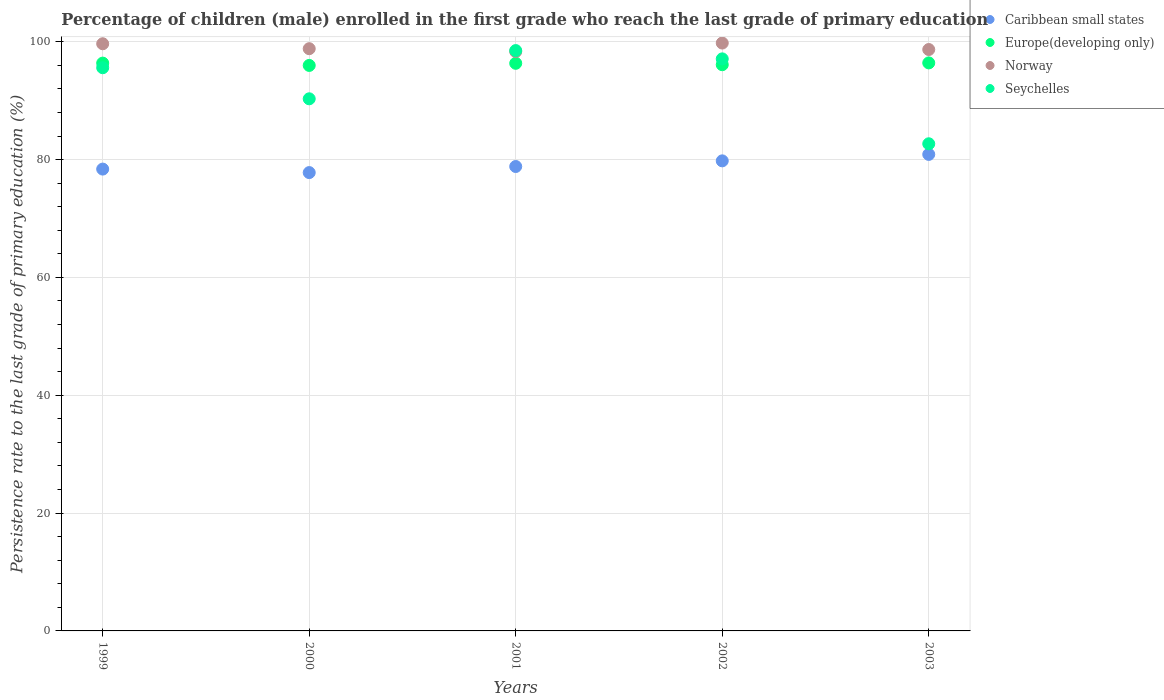Is the number of dotlines equal to the number of legend labels?
Your response must be concise. Yes. What is the persistence rate of children in Seychelles in 2002?
Give a very brief answer. 97.1. Across all years, what is the maximum persistence rate of children in Europe(developing only)?
Offer a terse response. 96.41. Across all years, what is the minimum persistence rate of children in Caribbean small states?
Keep it short and to the point. 77.79. In which year was the persistence rate of children in Caribbean small states maximum?
Provide a short and direct response. 2003. In which year was the persistence rate of children in Caribbean small states minimum?
Your response must be concise. 2000. What is the total persistence rate of children in Europe(developing only) in the graph?
Offer a very short reply. 481.22. What is the difference between the persistence rate of children in Europe(developing only) in 2000 and that in 2001?
Offer a terse response. -0.36. What is the difference between the persistence rate of children in Caribbean small states in 1999 and the persistence rate of children in Norway in 2000?
Give a very brief answer. -20.44. What is the average persistence rate of children in Caribbean small states per year?
Your answer should be very brief. 79.14. In the year 2001, what is the difference between the persistence rate of children in Europe(developing only) and persistence rate of children in Norway?
Your answer should be very brief. -1.98. In how many years, is the persistence rate of children in Norway greater than 48 %?
Offer a very short reply. 5. What is the ratio of the persistence rate of children in Seychelles in 2002 to that in 2003?
Make the answer very short. 1.17. Is the persistence rate of children in Norway in 2001 less than that in 2003?
Your response must be concise. Yes. What is the difference between the highest and the second highest persistence rate of children in Norway?
Your response must be concise. 0.12. What is the difference between the highest and the lowest persistence rate of children in Norway?
Your answer should be very brief. 1.45. Is it the case that in every year, the sum of the persistence rate of children in Europe(developing only) and persistence rate of children in Seychelles  is greater than the sum of persistence rate of children in Norway and persistence rate of children in Caribbean small states?
Give a very brief answer. No. How many dotlines are there?
Keep it short and to the point. 4. How many years are there in the graph?
Provide a short and direct response. 5. Does the graph contain grids?
Give a very brief answer. Yes. Where does the legend appear in the graph?
Your answer should be compact. Top right. How many legend labels are there?
Your answer should be very brief. 4. What is the title of the graph?
Keep it short and to the point. Percentage of children (male) enrolled in the first grade who reach the last grade of primary education. What is the label or title of the X-axis?
Offer a terse response. Years. What is the label or title of the Y-axis?
Your answer should be very brief. Persistence rate to the last grade of primary education (%). What is the Persistence rate to the last grade of primary education (%) in Caribbean small states in 1999?
Your answer should be compact. 78.39. What is the Persistence rate to the last grade of primary education (%) of Europe(developing only) in 1999?
Offer a terse response. 96.38. What is the Persistence rate to the last grade of primary education (%) of Norway in 1999?
Your answer should be very brief. 99.66. What is the Persistence rate to the last grade of primary education (%) of Seychelles in 1999?
Provide a succinct answer. 95.59. What is the Persistence rate to the last grade of primary education (%) in Caribbean small states in 2000?
Keep it short and to the point. 77.79. What is the Persistence rate to the last grade of primary education (%) of Europe(developing only) in 2000?
Make the answer very short. 95.98. What is the Persistence rate to the last grade of primary education (%) in Norway in 2000?
Give a very brief answer. 98.82. What is the Persistence rate to the last grade of primary education (%) in Seychelles in 2000?
Offer a very short reply. 90.32. What is the Persistence rate to the last grade of primary education (%) of Caribbean small states in 2001?
Provide a short and direct response. 78.83. What is the Persistence rate to the last grade of primary education (%) in Europe(developing only) in 2001?
Offer a very short reply. 96.34. What is the Persistence rate to the last grade of primary education (%) in Norway in 2001?
Provide a short and direct response. 98.33. What is the Persistence rate to the last grade of primary education (%) of Seychelles in 2001?
Ensure brevity in your answer.  98.5. What is the Persistence rate to the last grade of primary education (%) in Caribbean small states in 2002?
Ensure brevity in your answer.  79.79. What is the Persistence rate to the last grade of primary education (%) in Europe(developing only) in 2002?
Provide a short and direct response. 96.1. What is the Persistence rate to the last grade of primary education (%) of Norway in 2002?
Offer a terse response. 99.78. What is the Persistence rate to the last grade of primary education (%) of Seychelles in 2002?
Offer a terse response. 97.1. What is the Persistence rate to the last grade of primary education (%) in Caribbean small states in 2003?
Offer a terse response. 80.88. What is the Persistence rate to the last grade of primary education (%) of Europe(developing only) in 2003?
Your answer should be compact. 96.41. What is the Persistence rate to the last grade of primary education (%) of Norway in 2003?
Offer a very short reply. 98.68. What is the Persistence rate to the last grade of primary education (%) of Seychelles in 2003?
Make the answer very short. 82.68. Across all years, what is the maximum Persistence rate to the last grade of primary education (%) of Caribbean small states?
Provide a succinct answer. 80.88. Across all years, what is the maximum Persistence rate to the last grade of primary education (%) of Europe(developing only)?
Provide a short and direct response. 96.41. Across all years, what is the maximum Persistence rate to the last grade of primary education (%) of Norway?
Offer a terse response. 99.78. Across all years, what is the maximum Persistence rate to the last grade of primary education (%) of Seychelles?
Give a very brief answer. 98.5. Across all years, what is the minimum Persistence rate to the last grade of primary education (%) of Caribbean small states?
Your response must be concise. 77.79. Across all years, what is the minimum Persistence rate to the last grade of primary education (%) of Europe(developing only)?
Offer a very short reply. 95.98. Across all years, what is the minimum Persistence rate to the last grade of primary education (%) in Norway?
Provide a succinct answer. 98.33. Across all years, what is the minimum Persistence rate to the last grade of primary education (%) of Seychelles?
Give a very brief answer. 82.68. What is the total Persistence rate to the last grade of primary education (%) of Caribbean small states in the graph?
Give a very brief answer. 395.68. What is the total Persistence rate to the last grade of primary education (%) in Europe(developing only) in the graph?
Ensure brevity in your answer.  481.22. What is the total Persistence rate to the last grade of primary education (%) in Norway in the graph?
Provide a short and direct response. 495.27. What is the total Persistence rate to the last grade of primary education (%) of Seychelles in the graph?
Offer a terse response. 464.19. What is the difference between the Persistence rate to the last grade of primary education (%) in Caribbean small states in 1999 and that in 2000?
Your answer should be compact. 0.59. What is the difference between the Persistence rate to the last grade of primary education (%) of Europe(developing only) in 1999 and that in 2000?
Make the answer very short. 0.39. What is the difference between the Persistence rate to the last grade of primary education (%) in Norway in 1999 and that in 2000?
Your answer should be very brief. 0.84. What is the difference between the Persistence rate to the last grade of primary education (%) of Seychelles in 1999 and that in 2000?
Provide a short and direct response. 5.27. What is the difference between the Persistence rate to the last grade of primary education (%) of Caribbean small states in 1999 and that in 2001?
Ensure brevity in your answer.  -0.44. What is the difference between the Persistence rate to the last grade of primary education (%) of Europe(developing only) in 1999 and that in 2001?
Provide a short and direct response. 0.03. What is the difference between the Persistence rate to the last grade of primary education (%) of Norway in 1999 and that in 2001?
Give a very brief answer. 1.33. What is the difference between the Persistence rate to the last grade of primary education (%) of Seychelles in 1999 and that in 2001?
Your answer should be very brief. -2.91. What is the difference between the Persistence rate to the last grade of primary education (%) in Caribbean small states in 1999 and that in 2002?
Give a very brief answer. -1.4. What is the difference between the Persistence rate to the last grade of primary education (%) in Europe(developing only) in 1999 and that in 2002?
Your response must be concise. 0.27. What is the difference between the Persistence rate to the last grade of primary education (%) in Norway in 1999 and that in 2002?
Your answer should be compact. -0.12. What is the difference between the Persistence rate to the last grade of primary education (%) of Seychelles in 1999 and that in 2002?
Provide a short and direct response. -1.5. What is the difference between the Persistence rate to the last grade of primary education (%) of Caribbean small states in 1999 and that in 2003?
Your response must be concise. -2.49. What is the difference between the Persistence rate to the last grade of primary education (%) in Europe(developing only) in 1999 and that in 2003?
Provide a short and direct response. -0.04. What is the difference between the Persistence rate to the last grade of primary education (%) of Norway in 1999 and that in 2003?
Keep it short and to the point. 0.98. What is the difference between the Persistence rate to the last grade of primary education (%) of Seychelles in 1999 and that in 2003?
Ensure brevity in your answer.  12.91. What is the difference between the Persistence rate to the last grade of primary education (%) in Caribbean small states in 2000 and that in 2001?
Provide a succinct answer. -1.03. What is the difference between the Persistence rate to the last grade of primary education (%) in Europe(developing only) in 2000 and that in 2001?
Offer a very short reply. -0.36. What is the difference between the Persistence rate to the last grade of primary education (%) in Norway in 2000 and that in 2001?
Give a very brief answer. 0.5. What is the difference between the Persistence rate to the last grade of primary education (%) in Seychelles in 2000 and that in 2001?
Your response must be concise. -8.19. What is the difference between the Persistence rate to the last grade of primary education (%) of Caribbean small states in 2000 and that in 2002?
Offer a very short reply. -1.99. What is the difference between the Persistence rate to the last grade of primary education (%) in Europe(developing only) in 2000 and that in 2002?
Offer a terse response. -0.12. What is the difference between the Persistence rate to the last grade of primary education (%) of Norway in 2000 and that in 2002?
Keep it short and to the point. -0.96. What is the difference between the Persistence rate to the last grade of primary education (%) in Seychelles in 2000 and that in 2002?
Your answer should be compact. -6.78. What is the difference between the Persistence rate to the last grade of primary education (%) in Caribbean small states in 2000 and that in 2003?
Offer a terse response. -3.09. What is the difference between the Persistence rate to the last grade of primary education (%) in Europe(developing only) in 2000 and that in 2003?
Offer a terse response. -0.43. What is the difference between the Persistence rate to the last grade of primary education (%) of Norway in 2000 and that in 2003?
Offer a very short reply. 0.14. What is the difference between the Persistence rate to the last grade of primary education (%) of Seychelles in 2000 and that in 2003?
Offer a very short reply. 7.63. What is the difference between the Persistence rate to the last grade of primary education (%) of Caribbean small states in 2001 and that in 2002?
Your answer should be compact. -0.96. What is the difference between the Persistence rate to the last grade of primary education (%) in Europe(developing only) in 2001 and that in 2002?
Provide a succinct answer. 0.24. What is the difference between the Persistence rate to the last grade of primary education (%) of Norway in 2001 and that in 2002?
Your answer should be very brief. -1.45. What is the difference between the Persistence rate to the last grade of primary education (%) in Seychelles in 2001 and that in 2002?
Make the answer very short. 1.41. What is the difference between the Persistence rate to the last grade of primary education (%) of Caribbean small states in 2001 and that in 2003?
Offer a terse response. -2.06. What is the difference between the Persistence rate to the last grade of primary education (%) in Europe(developing only) in 2001 and that in 2003?
Ensure brevity in your answer.  -0.07. What is the difference between the Persistence rate to the last grade of primary education (%) of Norway in 2001 and that in 2003?
Your answer should be very brief. -0.36. What is the difference between the Persistence rate to the last grade of primary education (%) in Seychelles in 2001 and that in 2003?
Offer a terse response. 15.82. What is the difference between the Persistence rate to the last grade of primary education (%) of Caribbean small states in 2002 and that in 2003?
Your answer should be very brief. -1.1. What is the difference between the Persistence rate to the last grade of primary education (%) in Europe(developing only) in 2002 and that in 2003?
Offer a terse response. -0.31. What is the difference between the Persistence rate to the last grade of primary education (%) of Norway in 2002 and that in 2003?
Keep it short and to the point. 1.1. What is the difference between the Persistence rate to the last grade of primary education (%) of Seychelles in 2002 and that in 2003?
Offer a very short reply. 14.41. What is the difference between the Persistence rate to the last grade of primary education (%) of Caribbean small states in 1999 and the Persistence rate to the last grade of primary education (%) of Europe(developing only) in 2000?
Ensure brevity in your answer.  -17.6. What is the difference between the Persistence rate to the last grade of primary education (%) of Caribbean small states in 1999 and the Persistence rate to the last grade of primary education (%) of Norway in 2000?
Give a very brief answer. -20.44. What is the difference between the Persistence rate to the last grade of primary education (%) of Caribbean small states in 1999 and the Persistence rate to the last grade of primary education (%) of Seychelles in 2000?
Offer a terse response. -11.93. What is the difference between the Persistence rate to the last grade of primary education (%) of Europe(developing only) in 1999 and the Persistence rate to the last grade of primary education (%) of Norway in 2000?
Your answer should be compact. -2.45. What is the difference between the Persistence rate to the last grade of primary education (%) of Europe(developing only) in 1999 and the Persistence rate to the last grade of primary education (%) of Seychelles in 2000?
Keep it short and to the point. 6.06. What is the difference between the Persistence rate to the last grade of primary education (%) of Norway in 1999 and the Persistence rate to the last grade of primary education (%) of Seychelles in 2000?
Provide a short and direct response. 9.34. What is the difference between the Persistence rate to the last grade of primary education (%) in Caribbean small states in 1999 and the Persistence rate to the last grade of primary education (%) in Europe(developing only) in 2001?
Your response must be concise. -17.96. What is the difference between the Persistence rate to the last grade of primary education (%) of Caribbean small states in 1999 and the Persistence rate to the last grade of primary education (%) of Norway in 2001?
Offer a very short reply. -19.94. What is the difference between the Persistence rate to the last grade of primary education (%) of Caribbean small states in 1999 and the Persistence rate to the last grade of primary education (%) of Seychelles in 2001?
Provide a short and direct response. -20.12. What is the difference between the Persistence rate to the last grade of primary education (%) of Europe(developing only) in 1999 and the Persistence rate to the last grade of primary education (%) of Norway in 2001?
Keep it short and to the point. -1.95. What is the difference between the Persistence rate to the last grade of primary education (%) of Europe(developing only) in 1999 and the Persistence rate to the last grade of primary education (%) of Seychelles in 2001?
Your answer should be compact. -2.13. What is the difference between the Persistence rate to the last grade of primary education (%) in Norway in 1999 and the Persistence rate to the last grade of primary education (%) in Seychelles in 2001?
Offer a very short reply. 1.16. What is the difference between the Persistence rate to the last grade of primary education (%) of Caribbean small states in 1999 and the Persistence rate to the last grade of primary education (%) of Europe(developing only) in 2002?
Make the answer very short. -17.72. What is the difference between the Persistence rate to the last grade of primary education (%) in Caribbean small states in 1999 and the Persistence rate to the last grade of primary education (%) in Norway in 2002?
Offer a very short reply. -21.39. What is the difference between the Persistence rate to the last grade of primary education (%) in Caribbean small states in 1999 and the Persistence rate to the last grade of primary education (%) in Seychelles in 2002?
Give a very brief answer. -18.71. What is the difference between the Persistence rate to the last grade of primary education (%) in Europe(developing only) in 1999 and the Persistence rate to the last grade of primary education (%) in Norway in 2002?
Ensure brevity in your answer.  -3.41. What is the difference between the Persistence rate to the last grade of primary education (%) of Europe(developing only) in 1999 and the Persistence rate to the last grade of primary education (%) of Seychelles in 2002?
Offer a terse response. -0.72. What is the difference between the Persistence rate to the last grade of primary education (%) in Norway in 1999 and the Persistence rate to the last grade of primary education (%) in Seychelles in 2002?
Ensure brevity in your answer.  2.56. What is the difference between the Persistence rate to the last grade of primary education (%) of Caribbean small states in 1999 and the Persistence rate to the last grade of primary education (%) of Europe(developing only) in 2003?
Make the answer very short. -18.02. What is the difference between the Persistence rate to the last grade of primary education (%) in Caribbean small states in 1999 and the Persistence rate to the last grade of primary education (%) in Norway in 2003?
Your answer should be very brief. -20.29. What is the difference between the Persistence rate to the last grade of primary education (%) of Caribbean small states in 1999 and the Persistence rate to the last grade of primary education (%) of Seychelles in 2003?
Your response must be concise. -4.3. What is the difference between the Persistence rate to the last grade of primary education (%) of Europe(developing only) in 1999 and the Persistence rate to the last grade of primary education (%) of Norway in 2003?
Your answer should be compact. -2.31. What is the difference between the Persistence rate to the last grade of primary education (%) of Europe(developing only) in 1999 and the Persistence rate to the last grade of primary education (%) of Seychelles in 2003?
Your response must be concise. 13.69. What is the difference between the Persistence rate to the last grade of primary education (%) in Norway in 1999 and the Persistence rate to the last grade of primary education (%) in Seychelles in 2003?
Ensure brevity in your answer.  16.98. What is the difference between the Persistence rate to the last grade of primary education (%) in Caribbean small states in 2000 and the Persistence rate to the last grade of primary education (%) in Europe(developing only) in 2001?
Offer a terse response. -18.55. What is the difference between the Persistence rate to the last grade of primary education (%) in Caribbean small states in 2000 and the Persistence rate to the last grade of primary education (%) in Norway in 2001?
Provide a succinct answer. -20.53. What is the difference between the Persistence rate to the last grade of primary education (%) in Caribbean small states in 2000 and the Persistence rate to the last grade of primary education (%) in Seychelles in 2001?
Your answer should be very brief. -20.71. What is the difference between the Persistence rate to the last grade of primary education (%) of Europe(developing only) in 2000 and the Persistence rate to the last grade of primary education (%) of Norway in 2001?
Your answer should be compact. -2.34. What is the difference between the Persistence rate to the last grade of primary education (%) in Europe(developing only) in 2000 and the Persistence rate to the last grade of primary education (%) in Seychelles in 2001?
Give a very brief answer. -2.52. What is the difference between the Persistence rate to the last grade of primary education (%) in Norway in 2000 and the Persistence rate to the last grade of primary education (%) in Seychelles in 2001?
Keep it short and to the point. 0.32. What is the difference between the Persistence rate to the last grade of primary education (%) in Caribbean small states in 2000 and the Persistence rate to the last grade of primary education (%) in Europe(developing only) in 2002?
Give a very brief answer. -18.31. What is the difference between the Persistence rate to the last grade of primary education (%) in Caribbean small states in 2000 and the Persistence rate to the last grade of primary education (%) in Norway in 2002?
Offer a terse response. -21.99. What is the difference between the Persistence rate to the last grade of primary education (%) in Caribbean small states in 2000 and the Persistence rate to the last grade of primary education (%) in Seychelles in 2002?
Offer a terse response. -19.3. What is the difference between the Persistence rate to the last grade of primary education (%) in Europe(developing only) in 2000 and the Persistence rate to the last grade of primary education (%) in Norway in 2002?
Your response must be concise. -3.8. What is the difference between the Persistence rate to the last grade of primary education (%) in Europe(developing only) in 2000 and the Persistence rate to the last grade of primary education (%) in Seychelles in 2002?
Keep it short and to the point. -1.11. What is the difference between the Persistence rate to the last grade of primary education (%) of Norway in 2000 and the Persistence rate to the last grade of primary education (%) of Seychelles in 2002?
Provide a short and direct response. 1.73. What is the difference between the Persistence rate to the last grade of primary education (%) of Caribbean small states in 2000 and the Persistence rate to the last grade of primary education (%) of Europe(developing only) in 2003?
Your answer should be very brief. -18.62. What is the difference between the Persistence rate to the last grade of primary education (%) in Caribbean small states in 2000 and the Persistence rate to the last grade of primary education (%) in Norway in 2003?
Give a very brief answer. -20.89. What is the difference between the Persistence rate to the last grade of primary education (%) in Caribbean small states in 2000 and the Persistence rate to the last grade of primary education (%) in Seychelles in 2003?
Provide a succinct answer. -4.89. What is the difference between the Persistence rate to the last grade of primary education (%) in Europe(developing only) in 2000 and the Persistence rate to the last grade of primary education (%) in Norway in 2003?
Offer a terse response. -2.7. What is the difference between the Persistence rate to the last grade of primary education (%) in Europe(developing only) in 2000 and the Persistence rate to the last grade of primary education (%) in Seychelles in 2003?
Your answer should be very brief. 13.3. What is the difference between the Persistence rate to the last grade of primary education (%) of Norway in 2000 and the Persistence rate to the last grade of primary education (%) of Seychelles in 2003?
Make the answer very short. 16.14. What is the difference between the Persistence rate to the last grade of primary education (%) in Caribbean small states in 2001 and the Persistence rate to the last grade of primary education (%) in Europe(developing only) in 2002?
Your response must be concise. -17.28. What is the difference between the Persistence rate to the last grade of primary education (%) of Caribbean small states in 2001 and the Persistence rate to the last grade of primary education (%) of Norway in 2002?
Your response must be concise. -20.95. What is the difference between the Persistence rate to the last grade of primary education (%) of Caribbean small states in 2001 and the Persistence rate to the last grade of primary education (%) of Seychelles in 2002?
Ensure brevity in your answer.  -18.27. What is the difference between the Persistence rate to the last grade of primary education (%) in Europe(developing only) in 2001 and the Persistence rate to the last grade of primary education (%) in Norway in 2002?
Your answer should be very brief. -3.44. What is the difference between the Persistence rate to the last grade of primary education (%) in Europe(developing only) in 2001 and the Persistence rate to the last grade of primary education (%) in Seychelles in 2002?
Provide a short and direct response. -0.75. What is the difference between the Persistence rate to the last grade of primary education (%) of Norway in 2001 and the Persistence rate to the last grade of primary education (%) of Seychelles in 2002?
Keep it short and to the point. 1.23. What is the difference between the Persistence rate to the last grade of primary education (%) of Caribbean small states in 2001 and the Persistence rate to the last grade of primary education (%) of Europe(developing only) in 2003?
Your response must be concise. -17.58. What is the difference between the Persistence rate to the last grade of primary education (%) of Caribbean small states in 2001 and the Persistence rate to the last grade of primary education (%) of Norway in 2003?
Give a very brief answer. -19.86. What is the difference between the Persistence rate to the last grade of primary education (%) of Caribbean small states in 2001 and the Persistence rate to the last grade of primary education (%) of Seychelles in 2003?
Make the answer very short. -3.86. What is the difference between the Persistence rate to the last grade of primary education (%) of Europe(developing only) in 2001 and the Persistence rate to the last grade of primary education (%) of Norway in 2003?
Offer a terse response. -2.34. What is the difference between the Persistence rate to the last grade of primary education (%) of Europe(developing only) in 2001 and the Persistence rate to the last grade of primary education (%) of Seychelles in 2003?
Offer a terse response. 13.66. What is the difference between the Persistence rate to the last grade of primary education (%) of Norway in 2001 and the Persistence rate to the last grade of primary education (%) of Seychelles in 2003?
Offer a terse response. 15.64. What is the difference between the Persistence rate to the last grade of primary education (%) in Caribbean small states in 2002 and the Persistence rate to the last grade of primary education (%) in Europe(developing only) in 2003?
Your answer should be very brief. -16.63. What is the difference between the Persistence rate to the last grade of primary education (%) of Caribbean small states in 2002 and the Persistence rate to the last grade of primary education (%) of Norway in 2003?
Make the answer very short. -18.9. What is the difference between the Persistence rate to the last grade of primary education (%) in Caribbean small states in 2002 and the Persistence rate to the last grade of primary education (%) in Seychelles in 2003?
Provide a short and direct response. -2.9. What is the difference between the Persistence rate to the last grade of primary education (%) in Europe(developing only) in 2002 and the Persistence rate to the last grade of primary education (%) in Norway in 2003?
Provide a short and direct response. -2.58. What is the difference between the Persistence rate to the last grade of primary education (%) in Europe(developing only) in 2002 and the Persistence rate to the last grade of primary education (%) in Seychelles in 2003?
Provide a succinct answer. 13.42. What is the difference between the Persistence rate to the last grade of primary education (%) in Norway in 2002 and the Persistence rate to the last grade of primary education (%) in Seychelles in 2003?
Offer a terse response. 17.1. What is the average Persistence rate to the last grade of primary education (%) in Caribbean small states per year?
Make the answer very short. 79.14. What is the average Persistence rate to the last grade of primary education (%) in Europe(developing only) per year?
Offer a very short reply. 96.24. What is the average Persistence rate to the last grade of primary education (%) in Norway per year?
Your answer should be very brief. 99.05. What is the average Persistence rate to the last grade of primary education (%) in Seychelles per year?
Provide a succinct answer. 92.84. In the year 1999, what is the difference between the Persistence rate to the last grade of primary education (%) in Caribbean small states and Persistence rate to the last grade of primary education (%) in Europe(developing only)?
Offer a very short reply. -17.99. In the year 1999, what is the difference between the Persistence rate to the last grade of primary education (%) of Caribbean small states and Persistence rate to the last grade of primary education (%) of Norway?
Your response must be concise. -21.27. In the year 1999, what is the difference between the Persistence rate to the last grade of primary education (%) of Caribbean small states and Persistence rate to the last grade of primary education (%) of Seychelles?
Your response must be concise. -17.2. In the year 1999, what is the difference between the Persistence rate to the last grade of primary education (%) of Europe(developing only) and Persistence rate to the last grade of primary education (%) of Norway?
Offer a very short reply. -3.29. In the year 1999, what is the difference between the Persistence rate to the last grade of primary education (%) of Europe(developing only) and Persistence rate to the last grade of primary education (%) of Seychelles?
Make the answer very short. 0.78. In the year 1999, what is the difference between the Persistence rate to the last grade of primary education (%) in Norway and Persistence rate to the last grade of primary education (%) in Seychelles?
Give a very brief answer. 4.07. In the year 2000, what is the difference between the Persistence rate to the last grade of primary education (%) in Caribbean small states and Persistence rate to the last grade of primary education (%) in Europe(developing only)?
Ensure brevity in your answer.  -18.19. In the year 2000, what is the difference between the Persistence rate to the last grade of primary education (%) in Caribbean small states and Persistence rate to the last grade of primary education (%) in Norway?
Your answer should be very brief. -21.03. In the year 2000, what is the difference between the Persistence rate to the last grade of primary education (%) in Caribbean small states and Persistence rate to the last grade of primary education (%) in Seychelles?
Give a very brief answer. -12.52. In the year 2000, what is the difference between the Persistence rate to the last grade of primary education (%) in Europe(developing only) and Persistence rate to the last grade of primary education (%) in Norway?
Ensure brevity in your answer.  -2.84. In the year 2000, what is the difference between the Persistence rate to the last grade of primary education (%) in Europe(developing only) and Persistence rate to the last grade of primary education (%) in Seychelles?
Keep it short and to the point. 5.66. In the year 2000, what is the difference between the Persistence rate to the last grade of primary education (%) in Norway and Persistence rate to the last grade of primary education (%) in Seychelles?
Offer a terse response. 8.51. In the year 2001, what is the difference between the Persistence rate to the last grade of primary education (%) in Caribbean small states and Persistence rate to the last grade of primary education (%) in Europe(developing only)?
Provide a succinct answer. -17.52. In the year 2001, what is the difference between the Persistence rate to the last grade of primary education (%) of Caribbean small states and Persistence rate to the last grade of primary education (%) of Norway?
Give a very brief answer. -19.5. In the year 2001, what is the difference between the Persistence rate to the last grade of primary education (%) in Caribbean small states and Persistence rate to the last grade of primary education (%) in Seychelles?
Provide a succinct answer. -19.68. In the year 2001, what is the difference between the Persistence rate to the last grade of primary education (%) in Europe(developing only) and Persistence rate to the last grade of primary education (%) in Norway?
Offer a very short reply. -1.98. In the year 2001, what is the difference between the Persistence rate to the last grade of primary education (%) in Europe(developing only) and Persistence rate to the last grade of primary education (%) in Seychelles?
Give a very brief answer. -2.16. In the year 2001, what is the difference between the Persistence rate to the last grade of primary education (%) of Norway and Persistence rate to the last grade of primary education (%) of Seychelles?
Your answer should be very brief. -0.18. In the year 2002, what is the difference between the Persistence rate to the last grade of primary education (%) of Caribbean small states and Persistence rate to the last grade of primary education (%) of Europe(developing only)?
Your response must be concise. -16.32. In the year 2002, what is the difference between the Persistence rate to the last grade of primary education (%) in Caribbean small states and Persistence rate to the last grade of primary education (%) in Norway?
Your answer should be compact. -20. In the year 2002, what is the difference between the Persistence rate to the last grade of primary education (%) of Caribbean small states and Persistence rate to the last grade of primary education (%) of Seychelles?
Ensure brevity in your answer.  -17.31. In the year 2002, what is the difference between the Persistence rate to the last grade of primary education (%) of Europe(developing only) and Persistence rate to the last grade of primary education (%) of Norway?
Make the answer very short. -3.68. In the year 2002, what is the difference between the Persistence rate to the last grade of primary education (%) of Europe(developing only) and Persistence rate to the last grade of primary education (%) of Seychelles?
Give a very brief answer. -0.99. In the year 2002, what is the difference between the Persistence rate to the last grade of primary education (%) of Norway and Persistence rate to the last grade of primary education (%) of Seychelles?
Keep it short and to the point. 2.69. In the year 2003, what is the difference between the Persistence rate to the last grade of primary education (%) in Caribbean small states and Persistence rate to the last grade of primary education (%) in Europe(developing only)?
Ensure brevity in your answer.  -15.53. In the year 2003, what is the difference between the Persistence rate to the last grade of primary education (%) of Caribbean small states and Persistence rate to the last grade of primary education (%) of Norway?
Your answer should be very brief. -17.8. In the year 2003, what is the difference between the Persistence rate to the last grade of primary education (%) in Caribbean small states and Persistence rate to the last grade of primary education (%) in Seychelles?
Offer a very short reply. -1.8. In the year 2003, what is the difference between the Persistence rate to the last grade of primary education (%) in Europe(developing only) and Persistence rate to the last grade of primary education (%) in Norway?
Give a very brief answer. -2.27. In the year 2003, what is the difference between the Persistence rate to the last grade of primary education (%) of Europe(developing only) and Persistence rate to the last grade of primary education (%) of Seychelles?
Your answer should be very brief. 13.73. In the year 2003, what is the difference between the Persistence rate to the last grade of primary education (%) of Norway and Persistence rate to the last grade of primary education (%) of Seychelles?
Give a very brief answer. 16. What is the ratio of the Persistence rate to the last grade of primary education (%) in Caribbean small states in 1999 to that in 2000?
Your response must be concise. 1.01. What is the ratio of the Persistence rate to the last grade of primary education (%) of Norway in 1999 to that in 2000?
Provide a succinct answer. 1.01. What is the ratio of the Persistence rate to the last grade of primary education (%) of Seychelles in 1999 to that in 2000?
Provide a short and direct response. 1.06. What is the ratio of the Persistence rate to the last grade of primary education (%) of Caribbean small states in 1999 to that in 2001?
Keep it short and to the point. 0.99. What is the ratio of the Persistence rate to the last grade of primary education (%) of Europe(developing only) in 1999 to that in 2001?
Provide a succinct answer. 1. What is the ratio of the Persistence rate to the last grade of primary education (%) of Norway in 1999 to that in 2001?
Keep it short and to the point. 1.01. What is the ratio of the Persistence rate to the last grade of primary education (%) of Seychelles in 1999 to that in 2001?
Make the answer very short. 0.97. What is the ratio of the Persistence rate to the last grade of primary education (%) of Caribbean small states in 1999 to that in 2002?
Make the answer very short. 0.98. What is the ratio of the Persistence rate to the last grade of primary education (%) in Seychelles in 1999 to that in 2002?
Your answer should be compact. 0.98. What is the ratio of the Persistence rate to the last grade of primary education (%) of Caribbean small states in 1999 to that in 2003?
Ensure brevity in your answer.  0.97. What is the ratio of the Persistence rate to the last grade of primary education (%) of Norway in 1999 to that in 2003?
Keep it short and to the point. 1.01. What is the ratio of the Persistence rate to the last grade of primary education (%) of Seychelles in 1999 to that in 2003?
Ensure brevity in your answer.  1.16. What is the ratio of the Persistence rate to the last grade of primary education (%) of Caribbean small states in 2000 to that in 2001?
Your response must be concise. 0.99. What is the ratio of the Persistence rate to the last grade of primary education (%) in Seychelles in 2000 to that in 2001?
Your answer should be very brief. 0.92. What is the ratio of the Persistence rate to the last grade of primary education (%) of Europe(developing only) in 2000 to that in 2002?
Provide a succinct answer. 1. What is the ratio of the Persistence rate to the last grade of primary education (%) of Seychelles in 2000 to that in 2002?
Your answer should be compact. 0.93. What is the ratio of the Persistence rate to the last grade of primary education (%) in Caribbean small states in 2000 to that in 2003?
Your answer should be very brief. 0.96. What is the ratio of the Persistence rate to the last grade of primary education (%) of Europe(developing only) in 2000 to that in 2003?
Ensure brevity in your answer.  1. What is the ratio of the Persistence rate to the last grade of primary education (%) of Seychelles in 2000 to that in 2003?
Make the answer very short. 1.09. What is the ratio of the Persistence rate to the last grade of primary education (%) of Norway in 2001 to that in 2002?
Make the answer very short. 0.99. What is the ratio of the Persistence rate to the last grade of primary education (%) in Seychelles in 2001 to that in 2002?
Make the answer very short. 1.01. What is the ratio of the Persistence rate to the last grade of primary education (%) of Caribbean small states in 2001 to that in 2003?
Offer a terse response. 0.97. What is the ratio of the Persistence rate to the last grade of primary education (%) in Europe(developing only) in 2001 to that in 2003?
Provide a short and direct response. 1. What is the ratio of the Persistence rate to the last grade of primary education (%) in Seychelles in 2001 to that in 2003?
Offer a terse response. 1.19. What is the ratio of the Persistence rate to the last grade of primary education (%) of Caribbean small states in 2002 to that in 2003?
Keep it short and to the point. 0.99. What is the ratio of the Persistence rate to the last grade of primary education (%) in Europe(developing only) in 2002 to that in 2003?
Ensure brevity in your answer.  1. What is the ratio of the Persistence rate to the last grade of primary education (%) of Norway in 2002 to that in 2003?
Provide a succinct answer. 1.01. What is the ratio of the Persistence rate to the last grade of primary education (%) of Seychelles in 2002 to that in 2003?
Make the answer very short. 1.17. What is the difference between the highest and the second highest Persistence rate to the last grade of primary education (%) in Caribbean small states?
Make the answer very short. 1.1. What is the difference between the highest and the second highest Persistence rate to the last grade of primary education (%) in Europe(developing only)?
Ensure brevity in your answer.  0.04. What is the difference between the highest and the second highest Persistence rate to the last grade of primary education (%) in Norway?
Your answer should be very brief. 0.12. What is the difference between the highest and the second highest Persistence rate to the last grade of primary education (%) in Seychelles?
Provide a succinct answer. 1.41. What is the difference between the highest and the lowest Persistence rate to the last grade of primary education (%) in Caribbean small states?
Keep it short and to the point. 3.09. What is the difference between the highest and the lowest Persistence rate to the last grade of primary education (%) in Europe(developing only)?
Make the answer very short. 0.43. What is the difference between the highest and the lowest Persistence rate to the last grade of primary education (%) in Norway?
Keep it short and to the point. 1.45. What is the difference between the highest and the lowest Persistence rate to the last grade of primary education (%) of Seychelles?
Give a very brief answer. 15.82. 